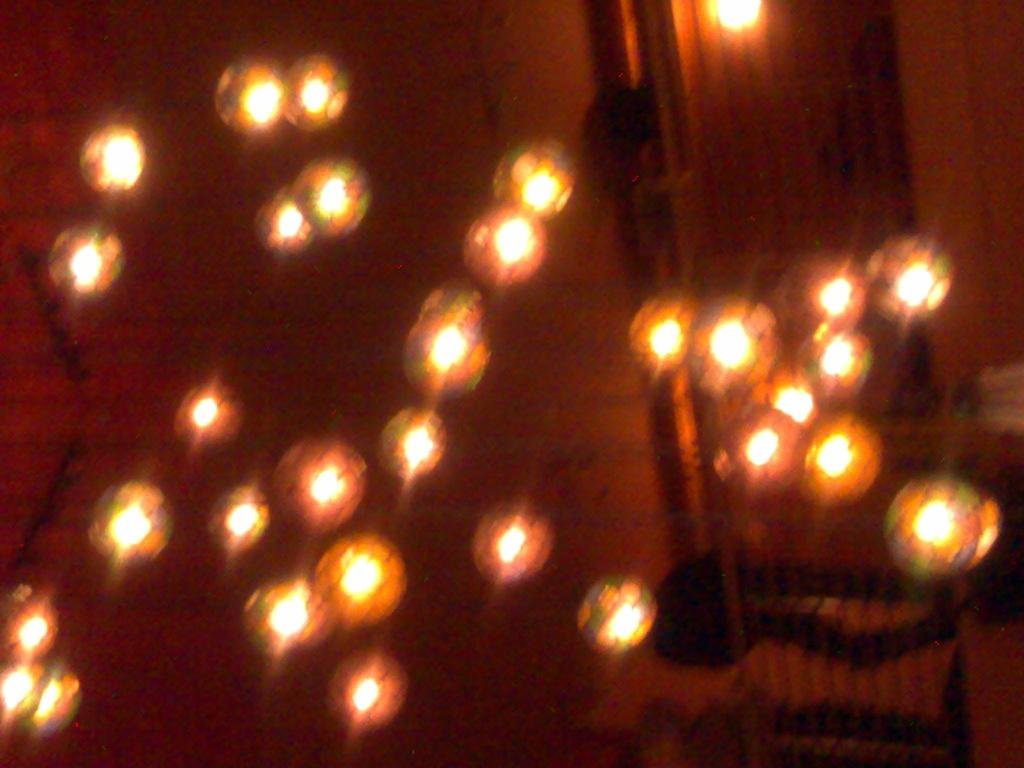What is located above the scene in the image? There is a ceiling in the image. What can be seen on the ceiling? There are many lights on the ceiling. What scent is associated with the ocean in the image? There is no ocean present in the image, so it is not possible to determine any associated scents. 